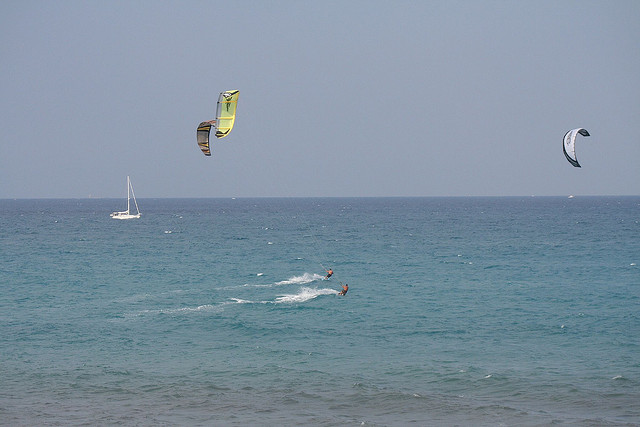Imagine the future of water sports. How do you see it evolving based on this image? In the future, water sports may evolve with advanced technology and innovative designs. New materials could make kite surfing equipment lighter and more durable, allowing for greater control and higher altitudes. Renewable energy innovations might allow surfers to harness and store wind energy for use during calmer periods, expanding the popularity and accessibility of the sport. Additionally, augmented reality could enhance the experience, providing real-time data on wind conditions, personalized training tips, and even creating virtual competitions with friends across the globe. The future promises a blend of thrilling physical activity with cutting-edge technology, making water sports more immersive and exciting than ever before. 